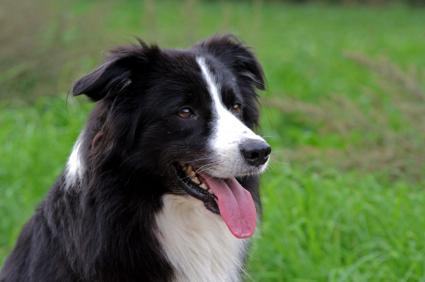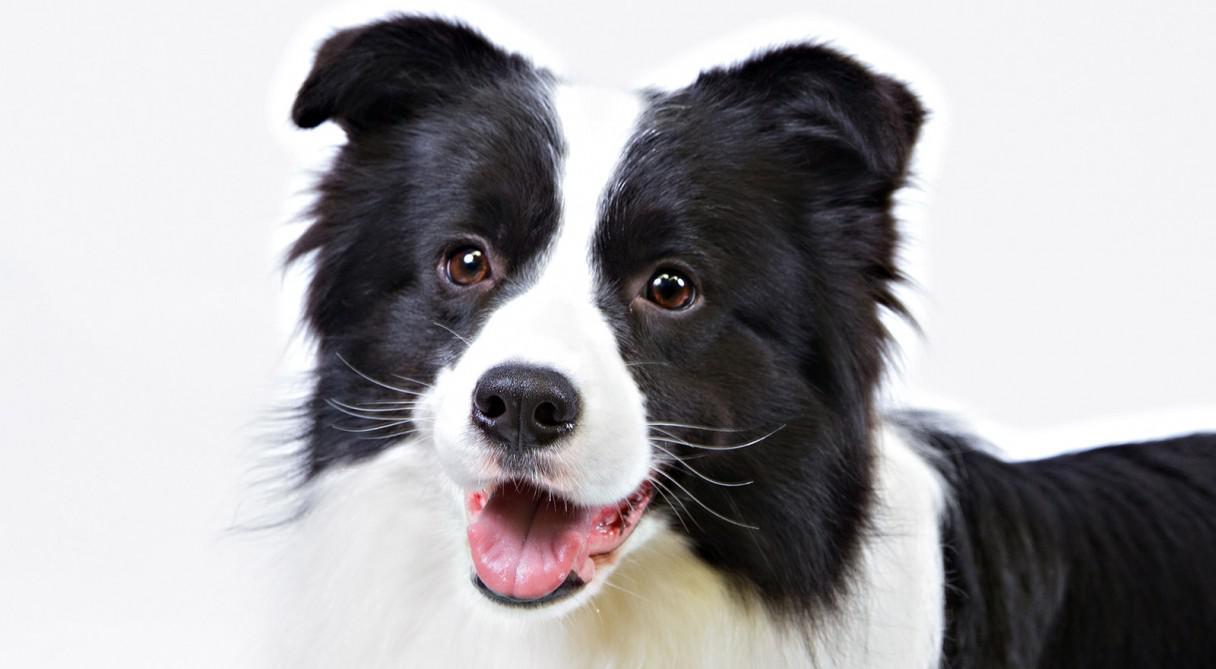The first image is the image on the left, the second image is the image on the right. Considering the images on both sides, is "The left image depicts only a canine-type animal on the grass." valid? Answer yes or no. Yes. 